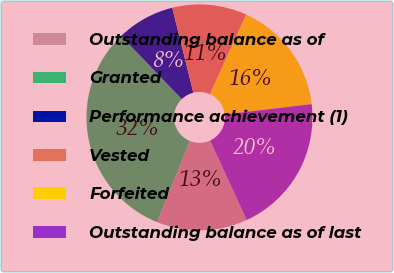Convert chart to OTSL. <chart><loc_0><loc_0><loc_500><loc_500><pie_chart><fcel>Outstanding balance as of<fcel>Granted<fcel>Performance achievement (1)<fcel>Vested<fcel>Forfeited<fcel>Outstanding balance as of last<nl><fcel>13.0%<fcel>31.67%<fcel>8.33%<fcel>10.66%<fcel>16.33%<fcel>20.01%<nl></chart> 